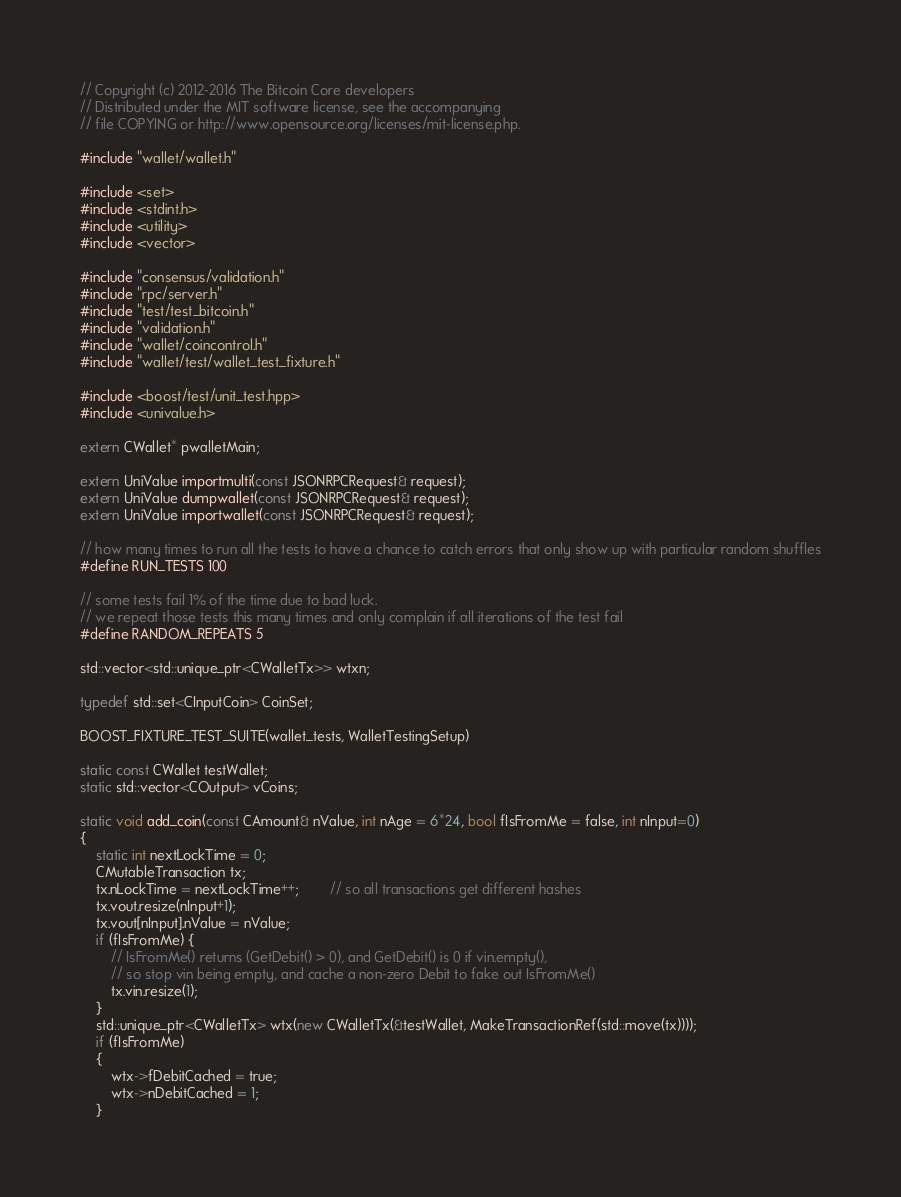<code> <loc_0><loc_0><loc_500><loc_500><_C++_>// Copyright (c) 2012-2016 The Bitcoin Core developers
// Distributed under the MIT software license, see the accompanying
// file COPYING or http://www.opensource.org/licenses/mit-license.php.

#include "wallet/wallet.h"

#include <set>
#include <stdint.h>
#include <utility>
#include <vector>

#include "consensus/validation.h"
#include "rpc/server.h"
#include "test/test_bitcoin.h"
#include "validation.h"
#include "wallet/coincontrol.h"
#include "wallet/test/wallet_test_fixture.h"

#include <boost/test/unit_test.hpp>
#include <univalue.h>

extern CWallet* pwalletMain;

extern UniValue importmulti(const JSONRPCRequest& request);
extern UniValue dumpwallet(const JSONRPCRequest& request);
extern UniValue importwallet(const JSONRPCRequest& request);

// how many times to run all the tests to have a chance to catch errors that only show up with particular random shuffles
#define RUN_TESTS 100

// some tests fail 1% of the time due to bad luck.
// we repeat those tests this many times and only complain if all iterations of the test fail
#define RANDOM_REPEATS 5

std::vector<std::unique_ptr<CWalletTx>> wtxn;

typedef std::set<CInputCoin> CoinSet;

BOOST_FIXTURE_TEST_SUITE(wallet_tests, WalletTestingSetup)

static const CWallet testWallet;
static std::vector<COutput> vCoins;

static void add_coin(const CAmount& nValue, int nAge = 6*24, bool fIsFromMe = false, int nInput=0)
{
    static int nextLockTime = 0;
    CMutableTransaction tx;
    tx.nLockTime = nextLockTime++;        // so all transactions get different hashes
    tx.vout.resize(nInput+1);
    tx.vout[nInput].nValue = nValue;
    if (fIsFromMe) {
        // IsFromMe() returns (GetDebit() > 0), and GetDebit() is 0 if vin.empty(),
        // so stop vin being empty, and cache a non-zero Debit to fake out IsFromMe()
        tx.vin.resize(1);
    }
    std::unique_ptr<CWalletTx> wtx(new CWalletTx(&testWallet, MakeTransactionRef(std::move(tx))));
    if (fIsFromMe)
    {
        wtx->fDebitCached = true;
        wtx->nDebitCached = 1;
    }</code> 